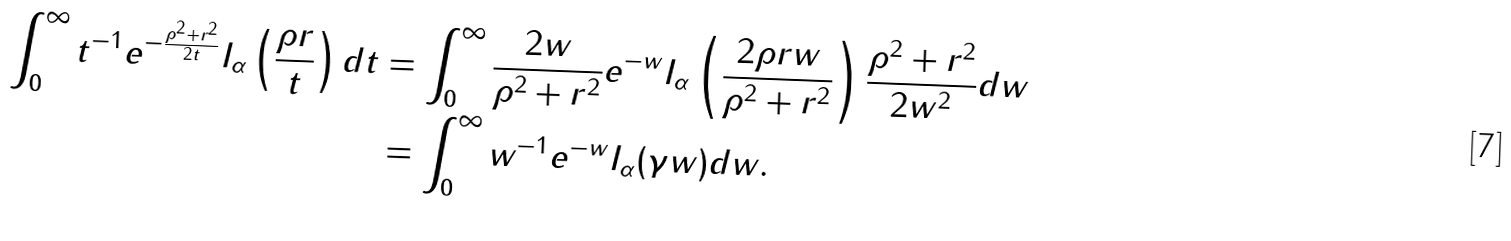Convert formula to latex. <formula><loc_0><loc_0><loc_500><loc_500>\int ^ { \infty } _ { 0 } t ^ { - 1 } e ^ { - \frac { \rho ^ { 2 } + r ^ { 2 } } { 2 t } } I _ { \alpha } \left ( \frac { \rho r } { t } \right ) d t & = \int ^ { \infty } _ { 0 } \frac { 2 w } { \rho ^ { 2 } + r ^ { 2 } } e ^ { - w } I _ { \alpha } \left ( \frac { 2 \rho r w } { \rho ^ { 2 } + r ^ { 2 } } \right ) \frac { \rho ^ { 2 } + r ^ { 2 } } { 2 w ^ { 2 } } d w \\ & = \int ^ { \infty } _ { 0 } w ^ { - 1 } e ^ { - w } I _ { \alpha } ( \gamma w ) d w .</formula> 